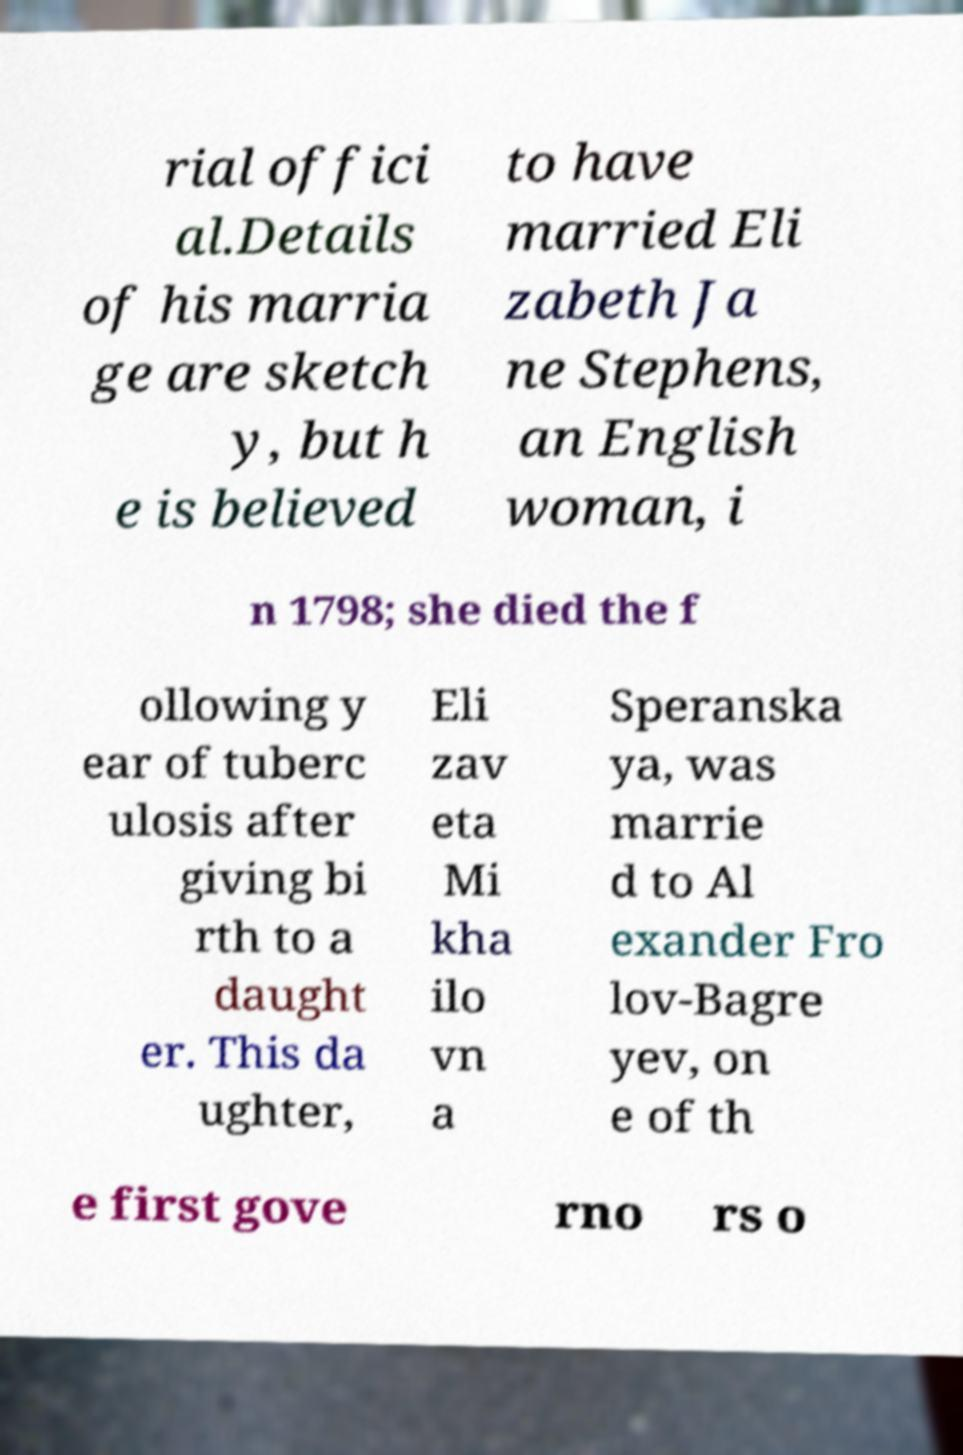What messages or text are displayed in this image? I need them in a readable, typed format. rial offici al.Details of his marria ge are sketch y, but h e is believed to have married Eli zabeth Ja ne Stephens, an English woman, i n 1798; she died the f ollowing y ear of tuberc ulosis after giving bi rth to a daught er. This da ughter, Eli zav eta Mi kha ilo vn a Speranska ya, was marrie d to Al exander Fro lov-Bagre yev, on e of th e first gove rno rs o 